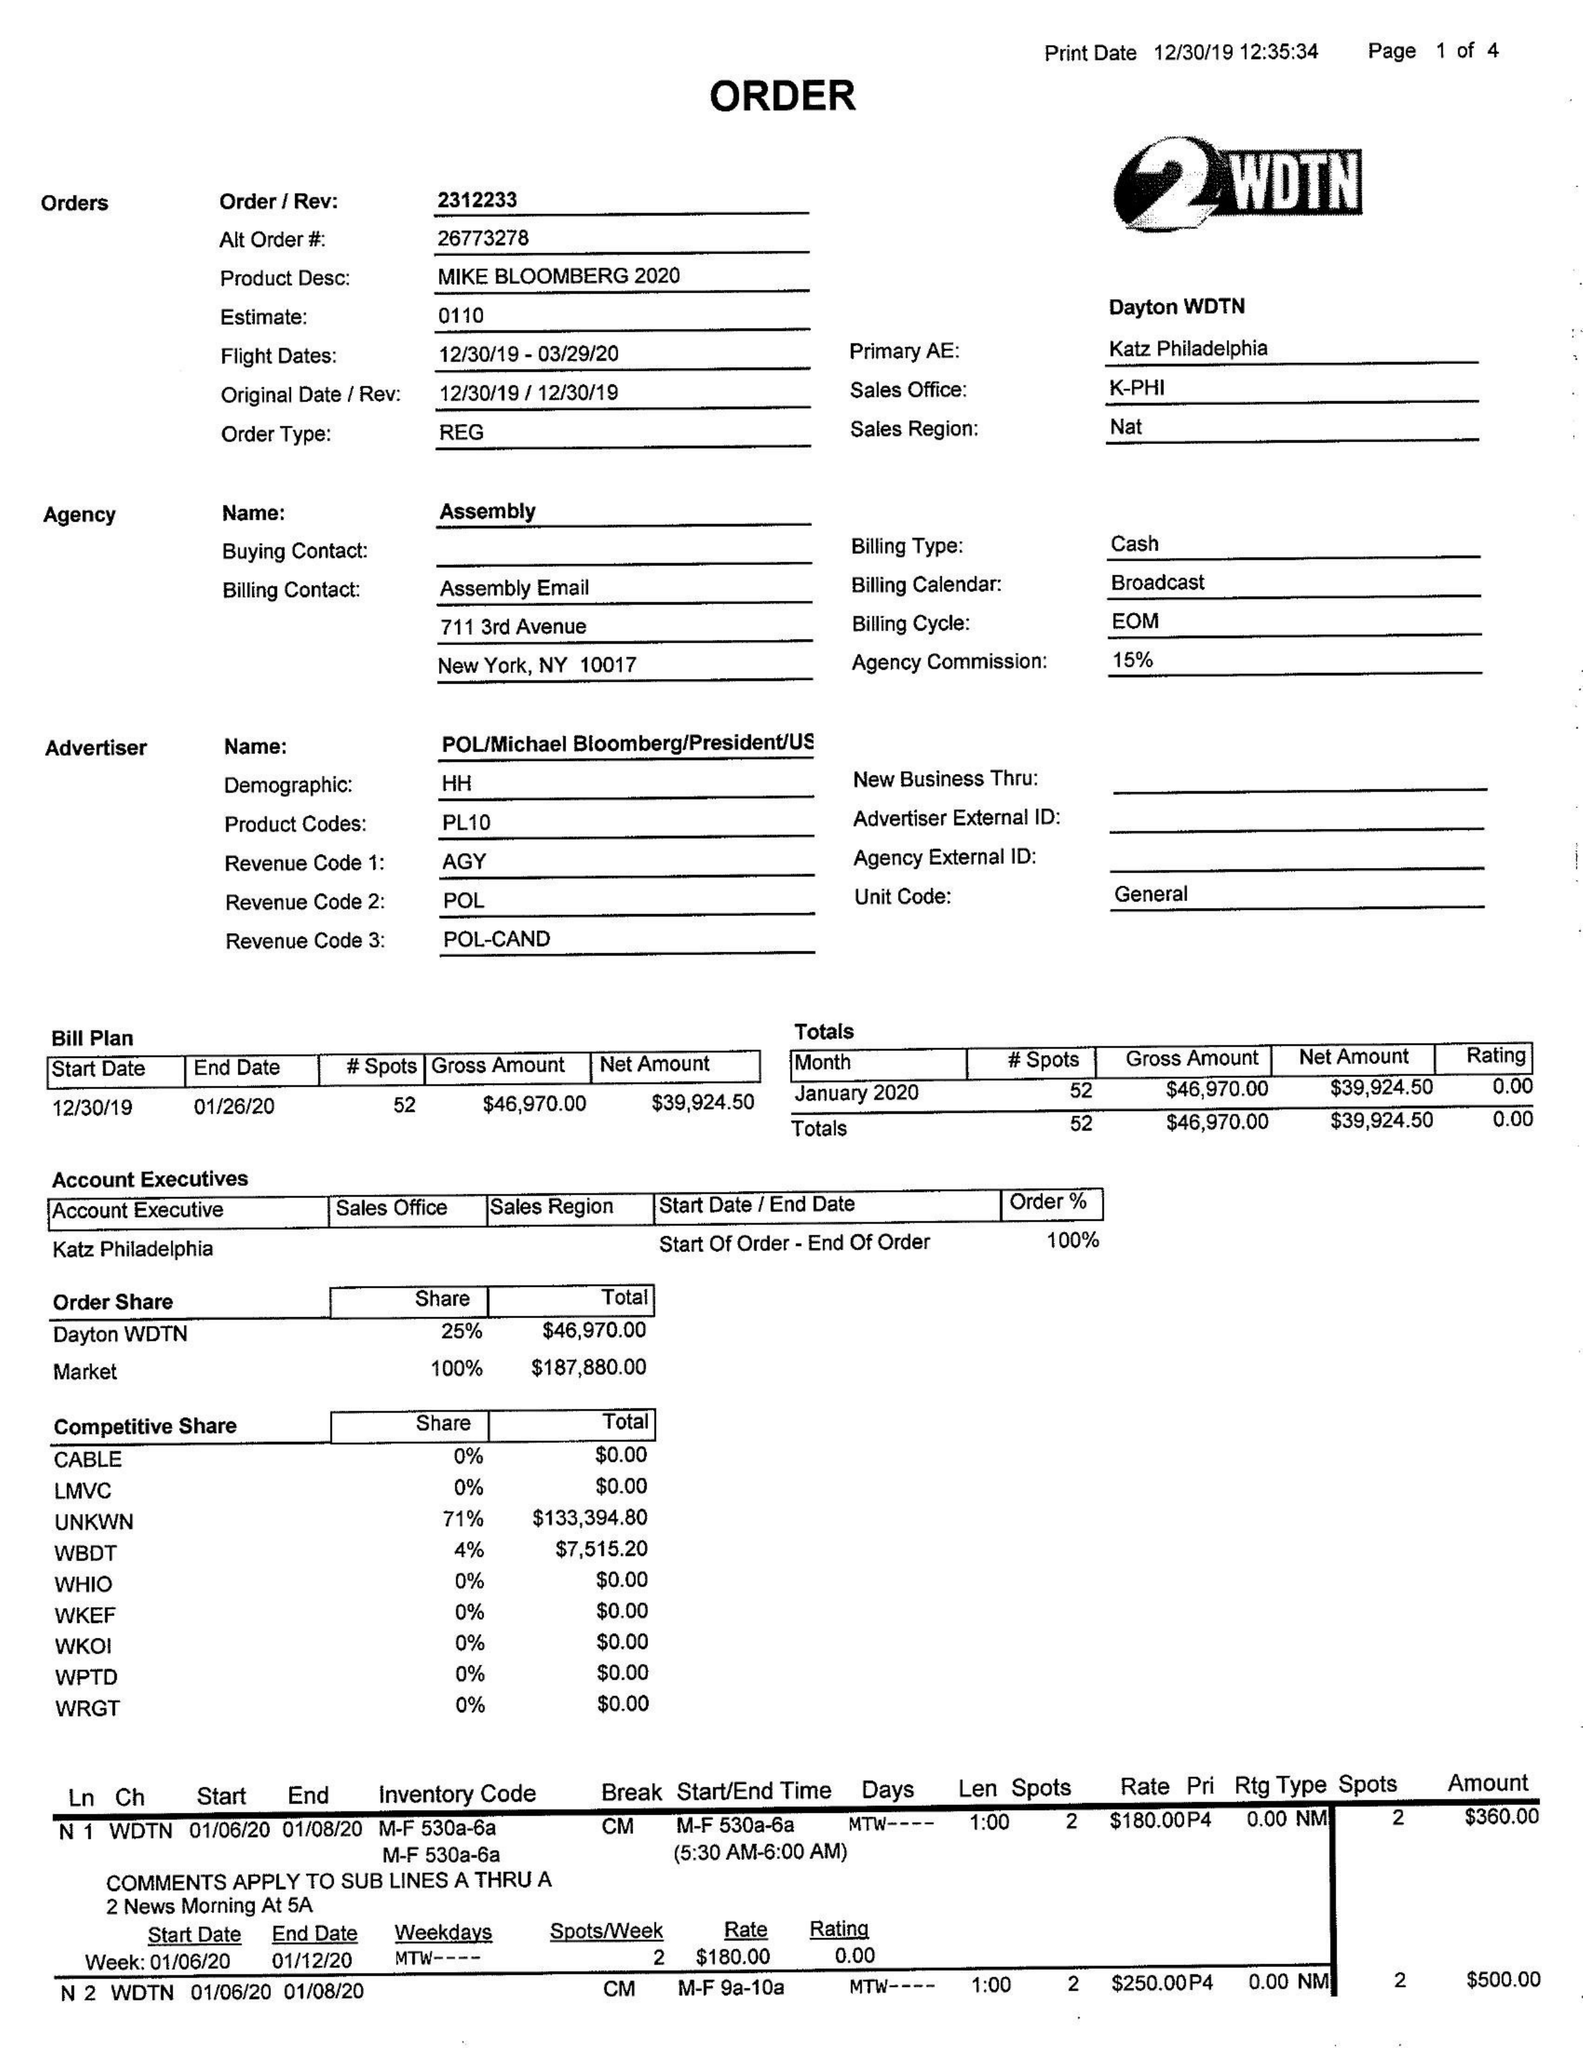What is the value for the gross_amount?
Answer the question using a single word or phrase. 46970.00 